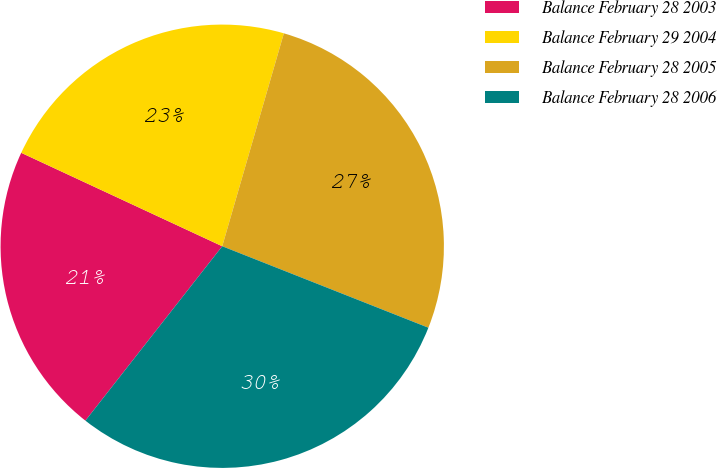<chart> <loc_0><loc_0><loc_500><loc_500><pie_chart><fcel>Balance February 28 2003<fcel>Balance February 29 2004<fcel>Balance February 28 2005<fcel>Balance February 28 2006<nl><fcel>21.34%<fcel>22.56%<fcel>26.51%<fcel>29.6%<nl></chart> 